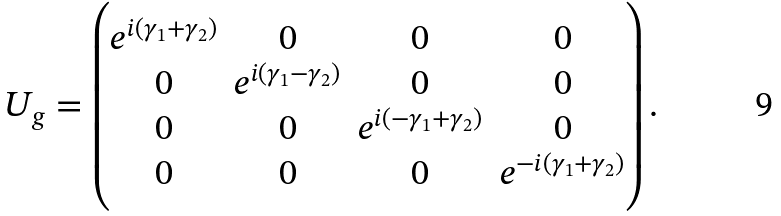<formula> <loc_0><loc_0><loc_500><loc_500>U _ { g } = \begin{pmatrix} e ^ { i ( \gamma _ { 1 } + \gamma _ { 2 } ) } & 0 & 0 & 0 \\ 0 & e ^ { i ( \gamma _ { 1 } - \gamma _ { 2 } ) } & 0 & 0 \\ 0 & 0 & e ^ { i ( - \gamma _ { 1 } + \gamma _ { 2 } ) } & 0 \\ 0 & 0 & 0 & e ^ { - i ( \gamma _ { 1 } + \gamma _ { 2 } ) } \\ \end{pmatrix} .</formula> 